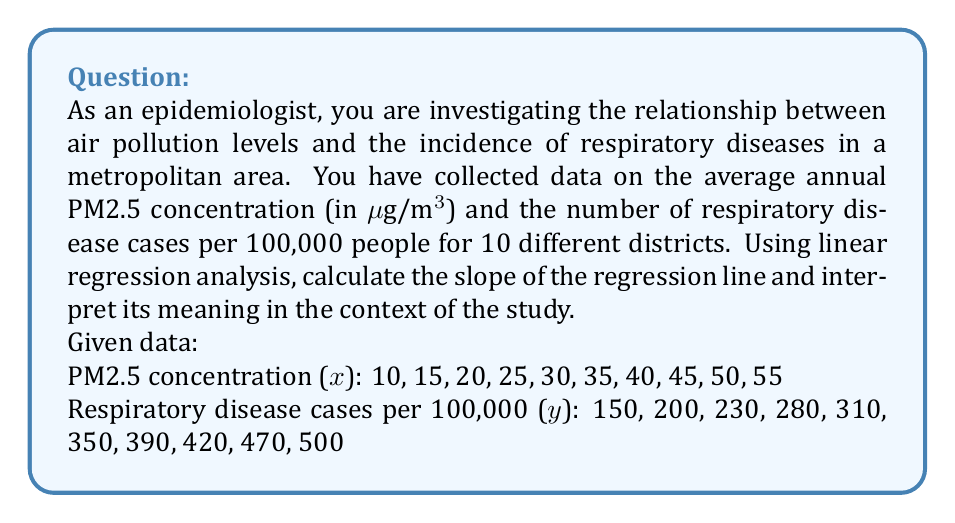Show me your answer to this math problem. To calculate the slope of the regression line, we'll use the formula:

$$ b = \frac{n\sum xy - \sum x \sum y}{n\sum x^2 - (\sum x)^2} $$

Where:
$b$ is the slope
$n$ is the number of data points
$x$ is the PM2.5 concentration
$y$ is the number of respiratory disease cases per 100,000

Step 1: Calculate the required sums:
$n = 10$
$\sum x = 325$
$\sum y = 3300$
$\sum xy = 123,750$
$\sum x^2 = 13,625$

Step 2: Apply the formula:

$$ b = \frac{10(123,750) - (325)(3300)}{10(13,625) - (325)^2} $$

$$ b = \frac{1,237,500 - 1,072,500}{136,250 - 105,625} $$

$$ b = \frac{165,000}{30,625} $$

$$ b = 5.387755102 $$

Step 3: Interpret the result:
The slope of 5.39 (rounded to two decimal places) indicates that for every 1 μg/m³ increase in PM2.5 concentration, there is an associated increase of approximately 5.39 respiratory disease cases per 100,000 people.

This positive slope suggests a strong positive correlation between air pollution levels and the incidence of respiratory diseases in the studied metropolitan area.
Answer: $b = 5.39$ cases per 100,000 people per 1 μg/m³ PM2.5 